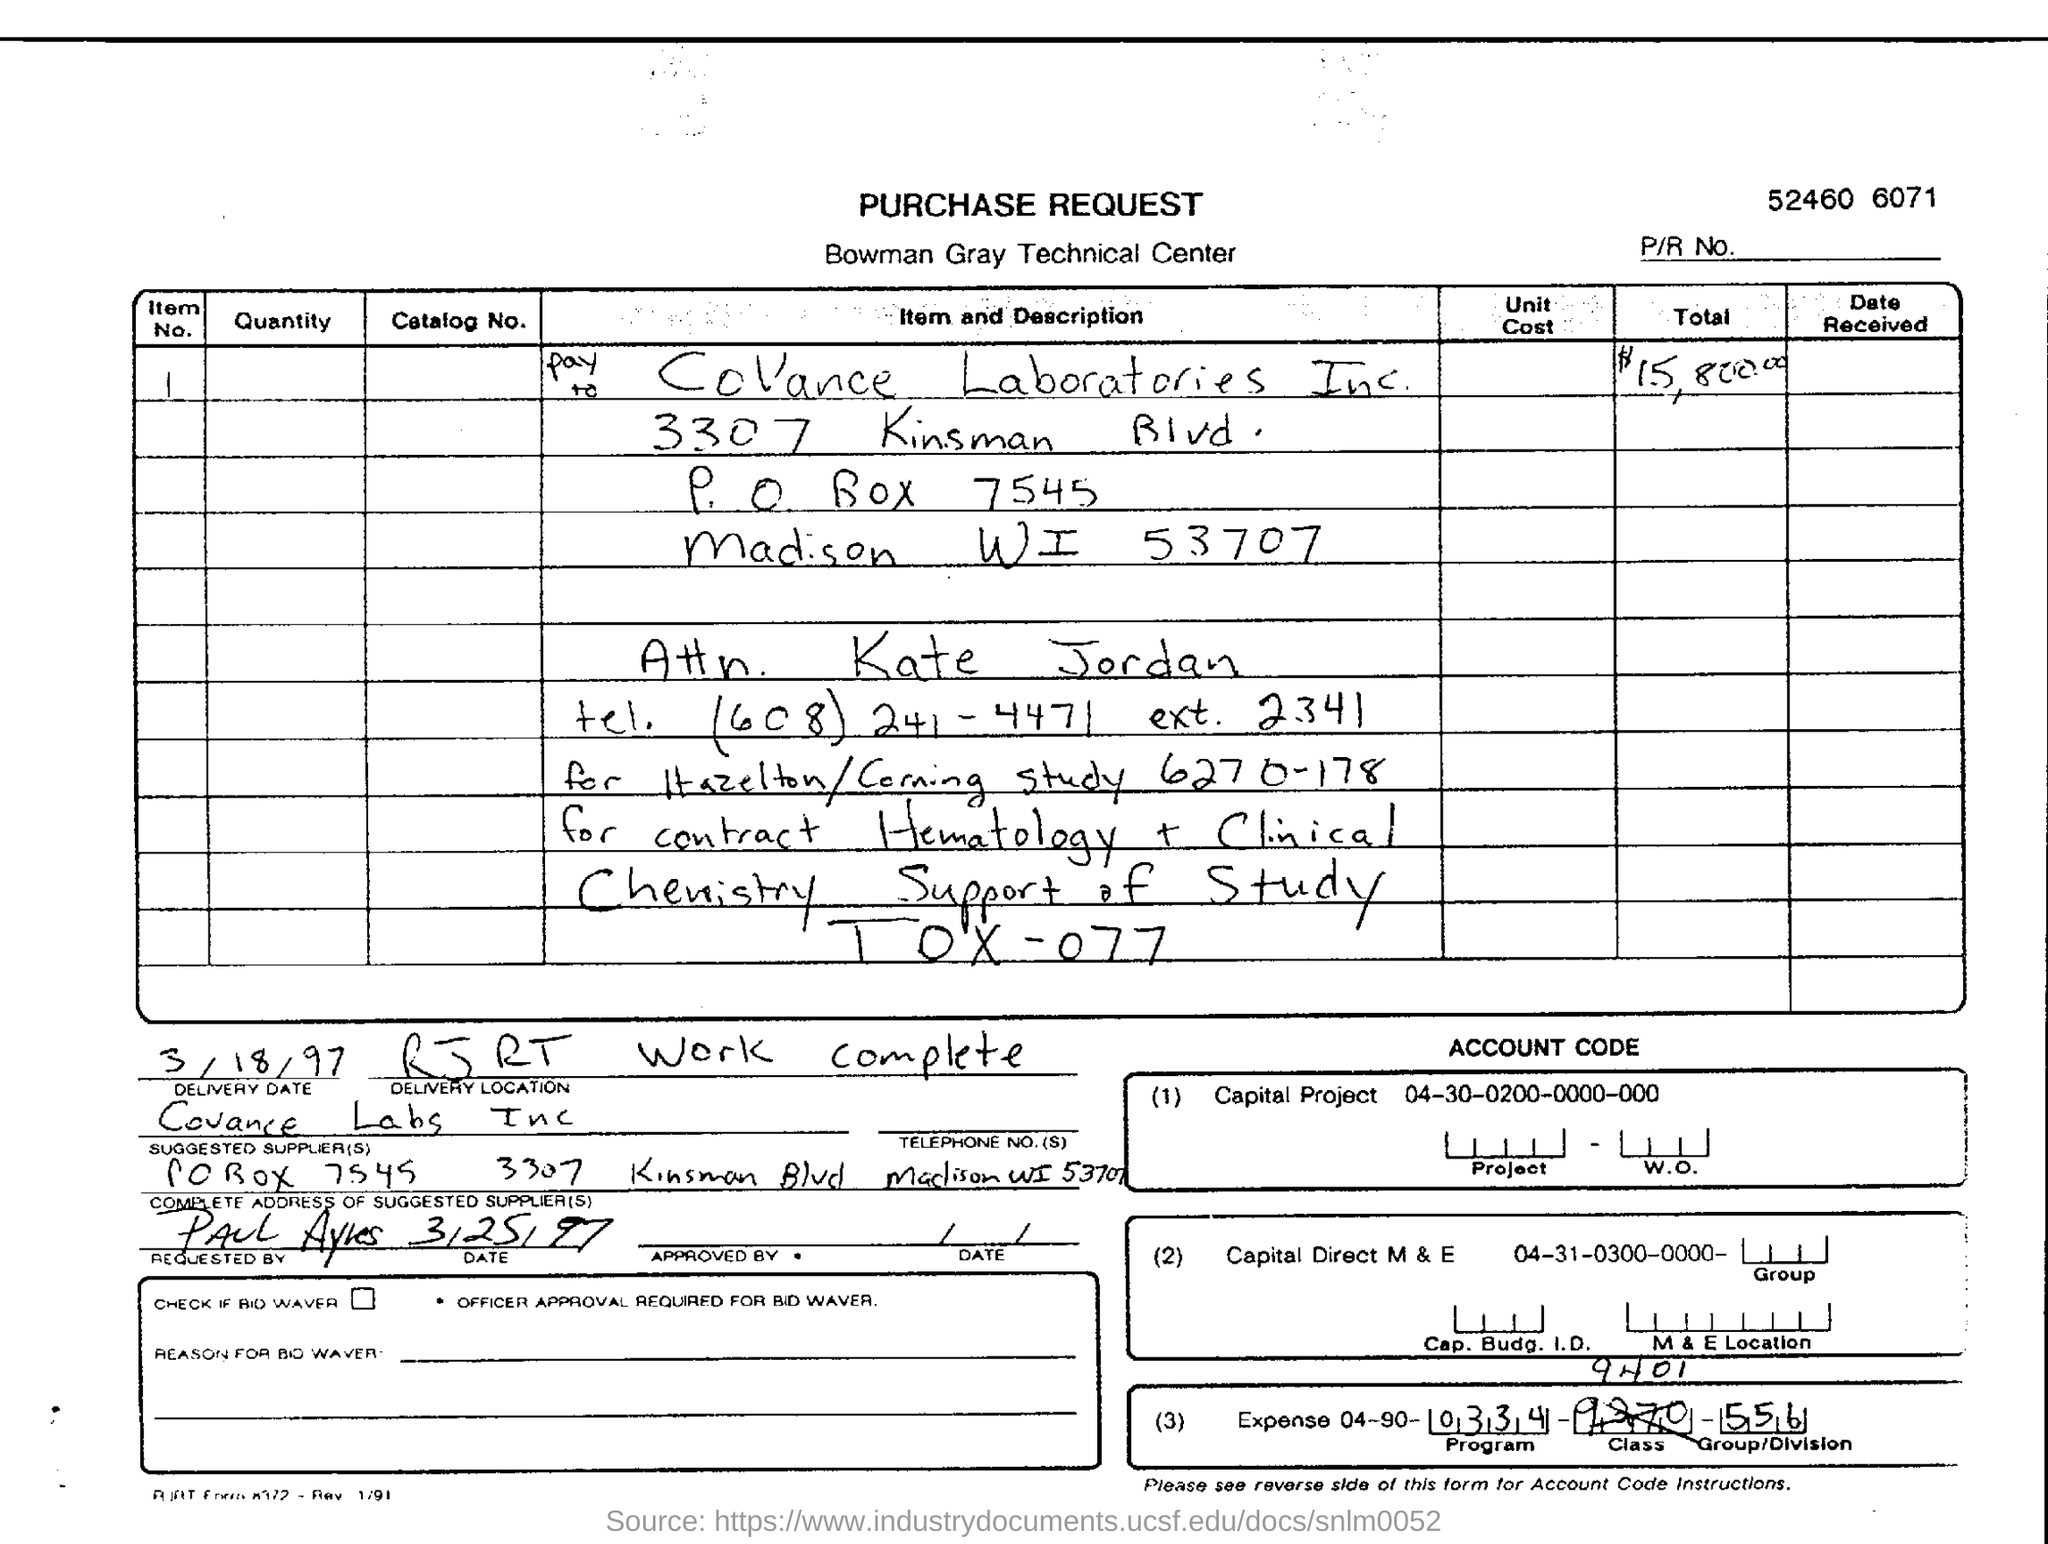Highlight a few significant elements in this photo. The delivery date provided in the purchase request form is March 18, 1997. The total amount mentioned in the purchase request form is $15,800.00. The sentence "Which company's purchase request form is this? Bowman Gray Technical Center.." is a question asking for information about the identity of the company associated with a purchase request form that is being referred to. The suggested supplier, as specified in the form, is Covance Labs Inc.. The item number provided in the purchase request form is 1.. 